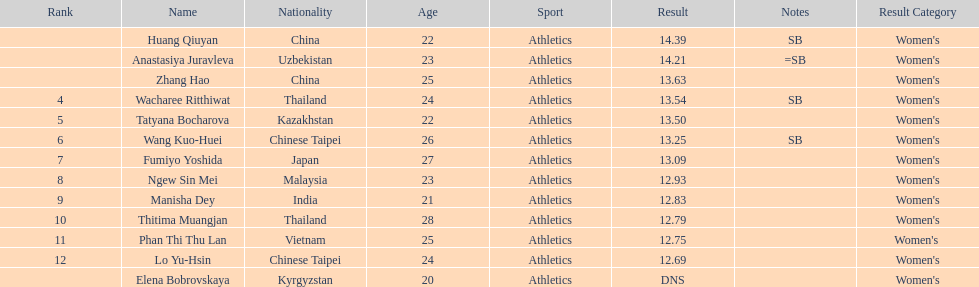How many competitors had less than 13.00 points? 6. I'm looking to parse the entire table for insights. Could you assist me with that? {'header': ['Rank', 'Name', 'Nationality', 'Age', 'Sport', 'Result', 'Notes', 'Result Category'], 'rows': [['', 'Huang Qiuyan', 'China', '22', 'Athletics', '14.39', 'SB', "Women's"], ['', 'Anastasiya Juravleva', 'Uzbekistan', '23', 'Athletics', '14.21', '=SB', "Women's"], ['', 'Zhang Hao', 'China', '25', 'Athletics', '13.63', '', "Women's"], ['4', 'Wacharee Ritthiwat', 'Thailand', '24', 'Athletics', '13.54', 'SB', "Women's"], ['5', 'Tatyana Bocharova', 'Kazakhstan', '22', 'Athletics', '13.50', '', "Women's"], ['6', 'Wang Kuo-Huei', 'Chinese Taipei', '26', 'Athletics', '13.25', 'SB', "Women's"], ['7', 'Fumiyo Yoshida', 'Japan', '27', 'Athletics', '13.09', '', "Women's"], ['8', 'Ngew Sin Mei', 'Malaysia', '23', 'Athletics', '12.93', '', "Women's"], ['9', 'Manisha Dey', 'India', '21', 'Athletics', '12.83', '', "Women's"], ['10', 'Thitima Muangjan', 'Thailand', '28', 'Athletics', '12.79', '', "Women's"], ['11', 'Phan Thi Thu Lan', 'Vietnam', '25', 'Athletics', '12.75', '', "Women's "], ['12', 'Lo Yu-Hsin', 'Chinese Taipei', '24', 'Athletics', '12.69', '', "Women's"], ['', 'Elena Bobrovskaya', 'Kyrgyzstan', '20', 'Athletics', 'DNS', '', "Women's"]]} 